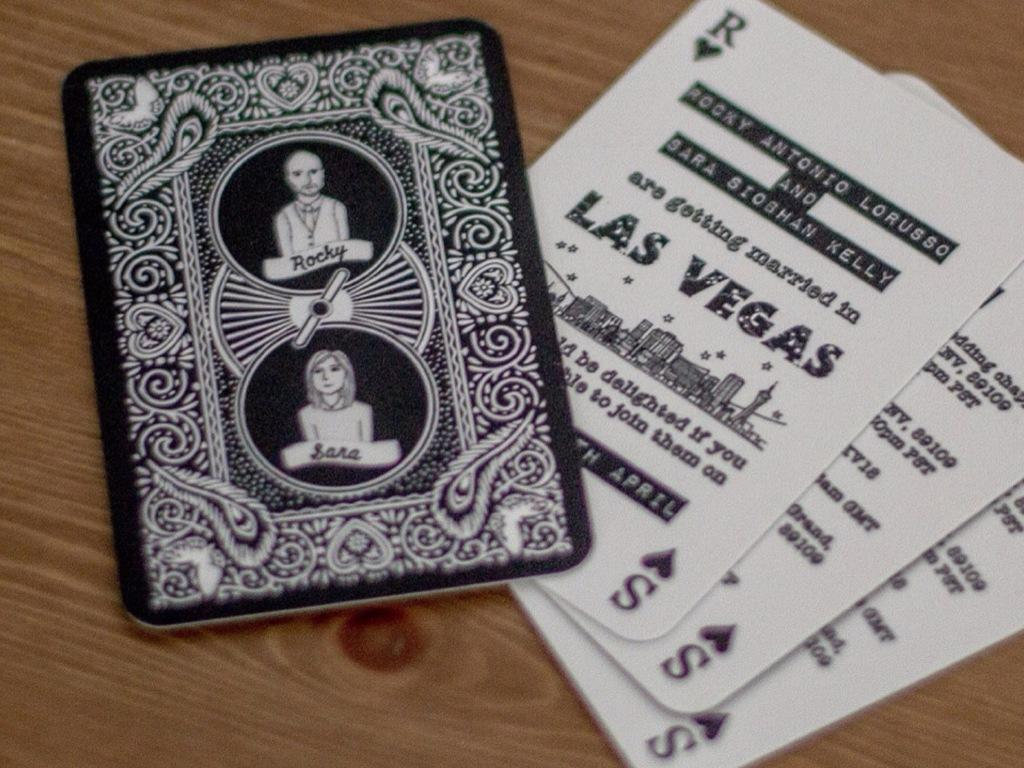What objects are present in the image? There are playing cards in the image. What is the playing cards placed on? The playing cards are on a wooden surface. Who is the owner of the playing cards in the image? There is no information about the owner of the playing cards in the image. What season is depicted in the image? The image does not depict a specific season, so it cannot be determined if it is summer or any other season. 